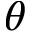Convert formula to latex. <formula><loc_0><loc_0><loc_500><loc_500>\theta</formula> 